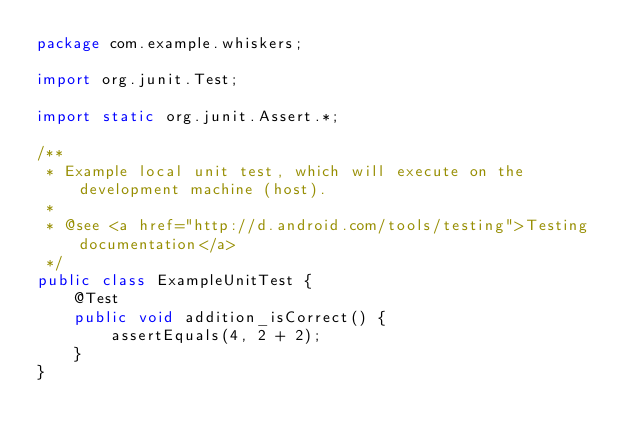<code> <loc_0><loc_0><loc_500><loc_500><_Java_>package com.example.whiskers;

import org.junit.Test;

import static org.junit.Assert.*;

/**
 * Example local unit test, which will execute on the development machine (host).
 *
 * @see <a href="http://d.android.com/tools/testing">Testing documentation</a>
 */
public class ExampleUnitTest {
    @Test
    public void addition_isCorrect() {
        assertEquals(4, 2 + 2);
    }
}</code> 